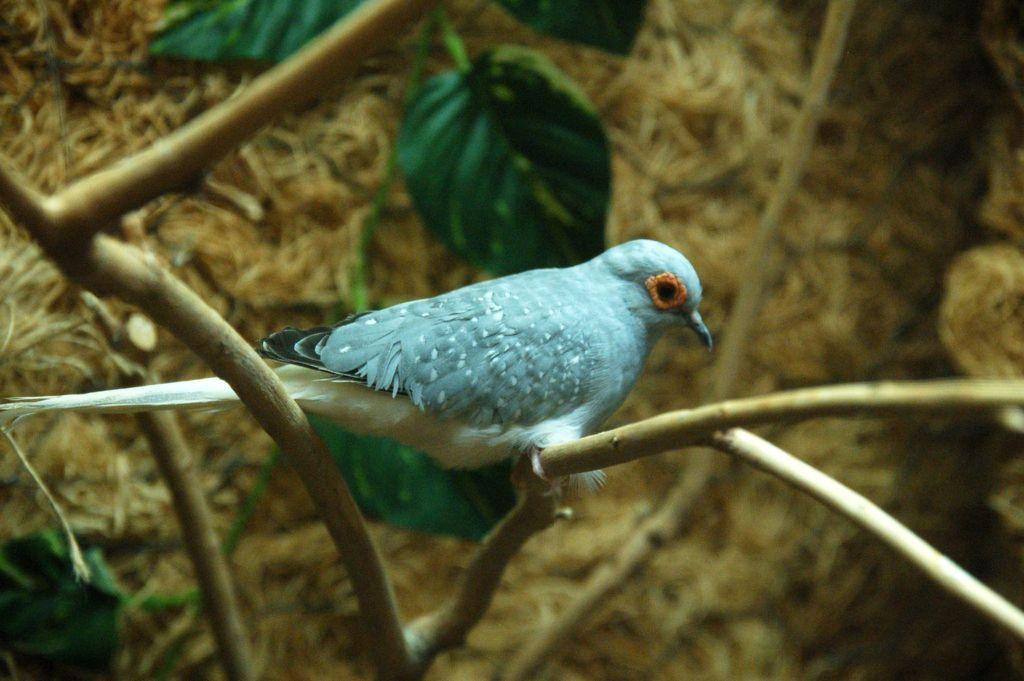What type of animal can be seen in the image? There is a bird in the image. Where is the bird located? The bird is sitting on a tree branch. What can be seen in the background of the image? There are leaves visible in the image. How would you describe the focus of the image? The background of the image is slightly blurred. How does the bird fulfill its wish while sitting on the tree branch in the image? There is no indication in the image that the bird has a wish or is fulfilling one. 